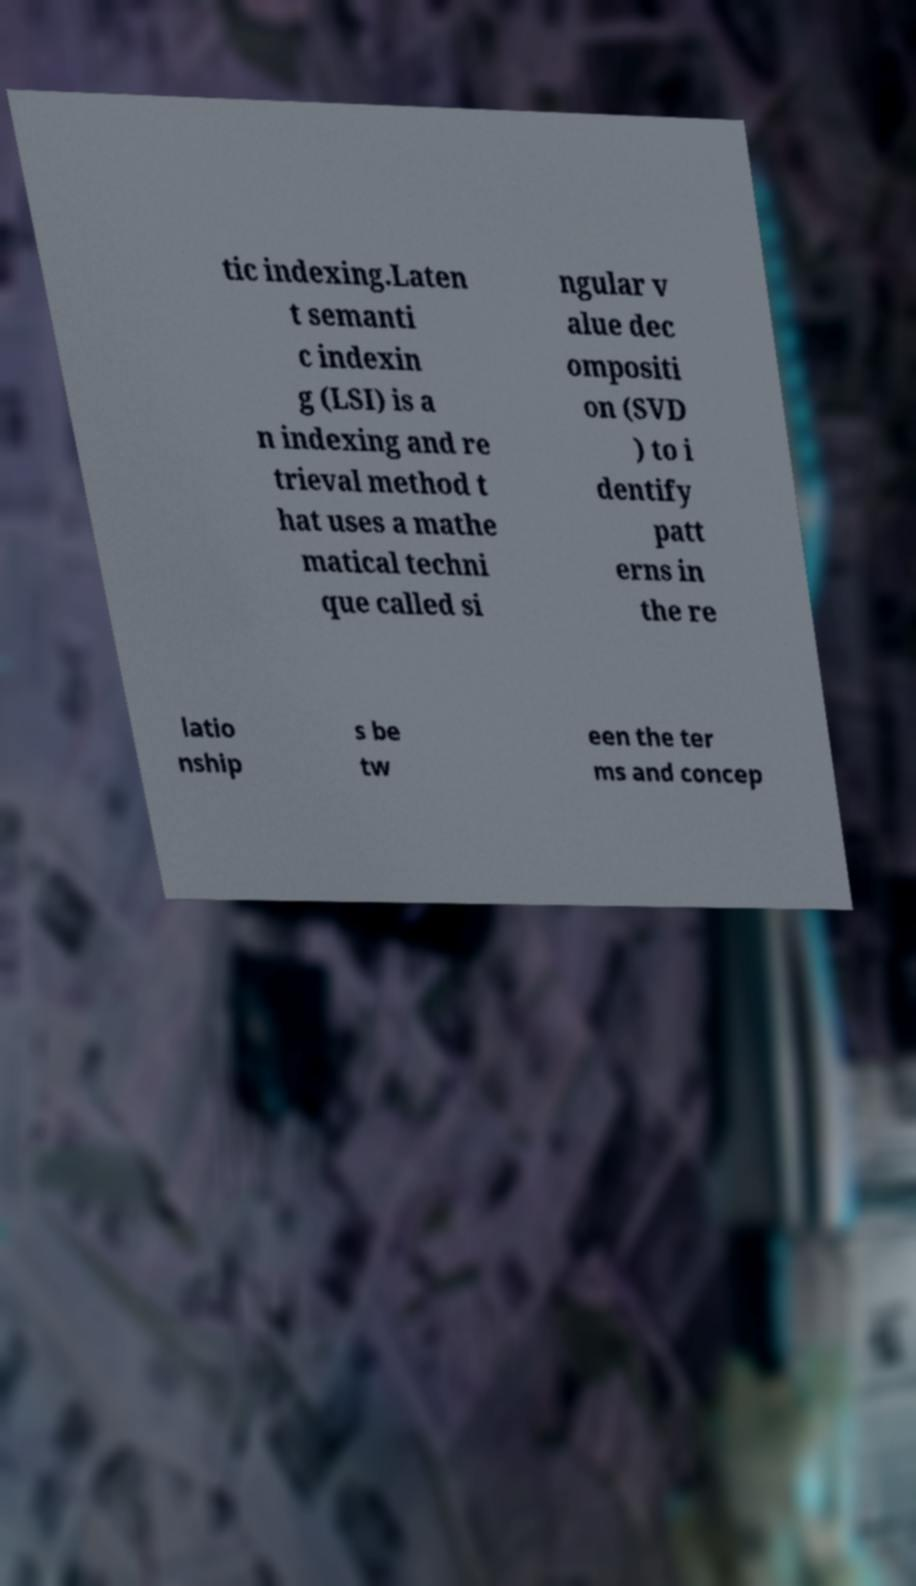There's text embedded in this image that I need extracted. Can you transcribe it verbatim? tic indexing.Laten t semanti c indexin g (LSI) is a n indexing and re trieval method t hat uses a mathe matical techni que called si ngular v alue dec ompositi on (SVD ) to i dentify patt erns in the re latio nship s be tw een the ter ms and concep 